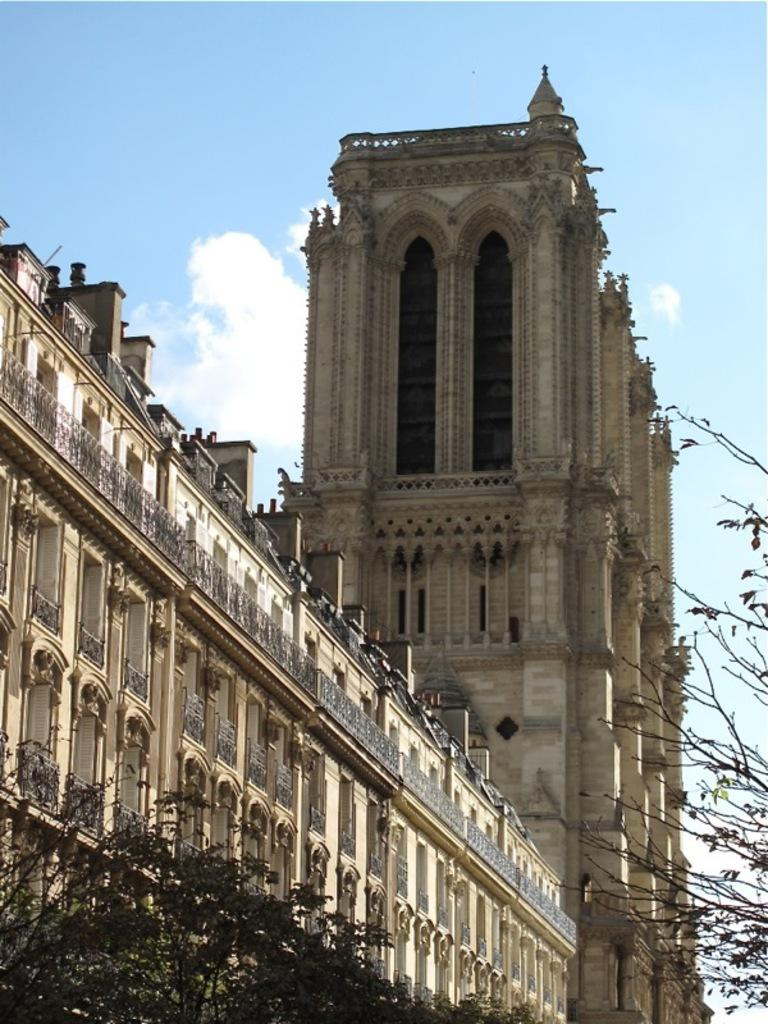What type of natural elements can be seen in the image? There are trees in the image. What type of man-made structure is present in the image? There is a building in the image. What part of the natural environment is visible in the image? The sky is visible in the image. What type of sweater is the tree wearing in the image? There are no sweaters present in the image, as trees are natural elements and do not wear clothing. 